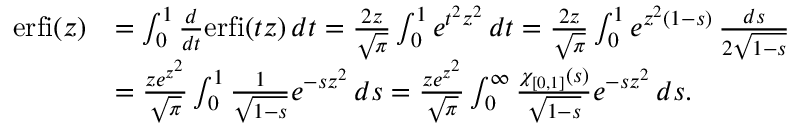<formula> <loc_0><loc_0><loc_500><loc_500>\begin{array} { r l } { e r f i ( z ) } & { = \int _ { 0 } ^ { 1 } \frac { d } { d t } e r f i ( t z ) \, d t = \frac { 2 z } { \sqrt { \pi } } \int _ { 0 } ^ { 1 } e ^ { t ^ { 2 } z ^ { 2 } } \, d t = \frac { 2 z } { \sqrt { \pi } } \int _ { 0 } ^ { 1 } e ^ { z ^ { 2 } ( 1 - s ) } \, \frac { d s } { 2 \sqrt { 1 - s } } } \\ & { = \frac { z e ^ { z ^ { 2 } } } { \sqrt { \pi } } \int _ { 0 } ^ { 1 } \frac { 1 } { \sqrt { 1 - s } } e ^ { - s z ^ { 2 } } \, d s = \frac { z e ^ { z ^ { 2 } } } { \sqrt { \pi } } \int _ { 0 } ^ { \infty } \frac { \chi _ { [ 0 , 1 ] } ( s ) } { \sqrt { 1 - s } } e ^ { - s z ^ { 2 } } \, d s . } \end{array}</formula> 